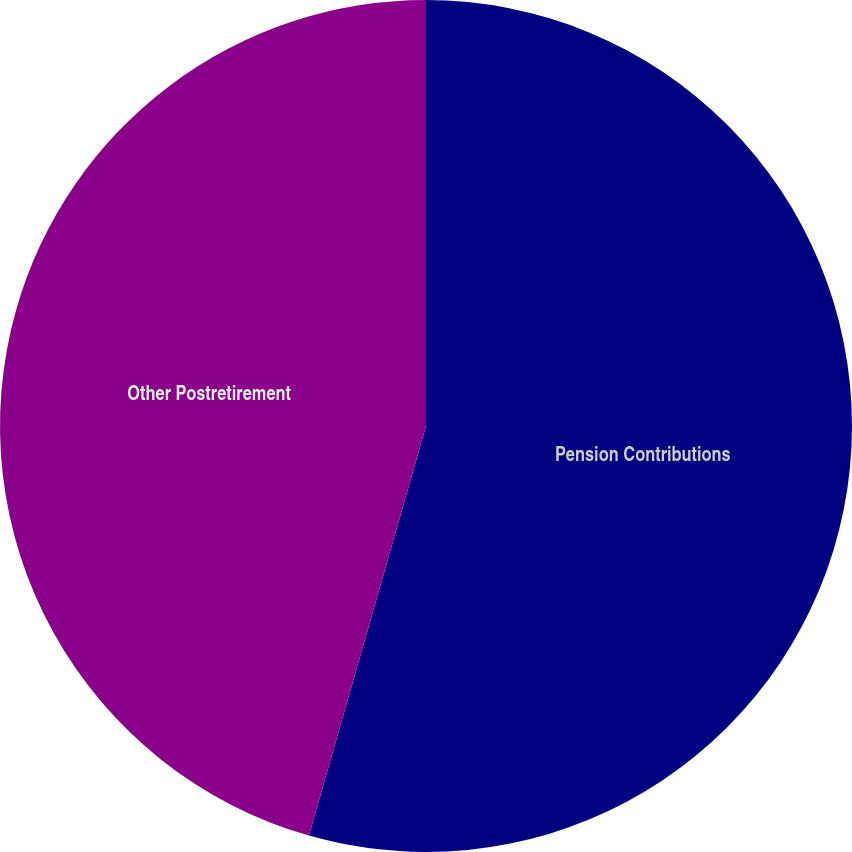Convert chart. <chart><loc_0><loc_0><loc_500><loc_500><pie_chart><fcel>Pension Contributions<fcel>Other Postretirement<nl><fcel>54.43%<fcel>45.57%<nl></chart> 